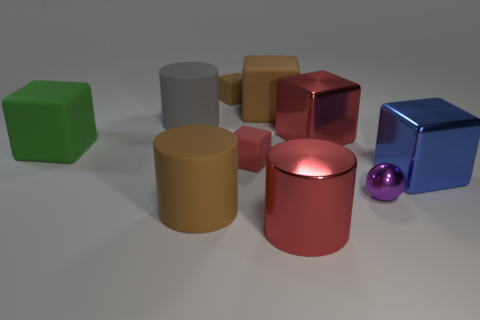Subtract all matte cylinders. How many cylinders are left? 1 Subtract all brown cubes. How many cubes are left? 4 Subtract all cylinders. How many objects are left? 7 Subtract all brown cylinders. How many green spheres are left? 0 Subtract all tiny rubber cubes. Subtract all brown things. How many objects are left? 5 Add 1 green rubber things. How many green rubber things are left? 2 Add 2 matte blocks. How many matte blocks exist? 6 Subtract 1 blue blocks. How many objects are left? 9 Subtract all cyan cylinders. Subtract all yellow cubes. How many cylinders are left? 3 